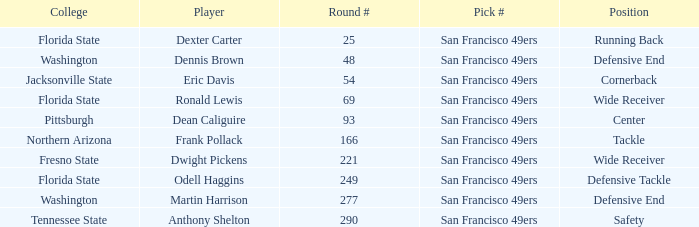What is the College with a Player that is dean caliguire? Pittsburgh. 